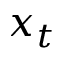<formula> <loc_0><loc_0><loc_500><loc_500>x _ { t }</formula> 